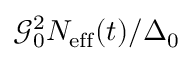Convert formula to latex. <formula><loc_0><loc_0><loc_500><loc_500>\mathcal { G } _ { 0 } ^ { 2 } N _ { e f f } ( t ) / \Delta _ { 0 }</formula> 